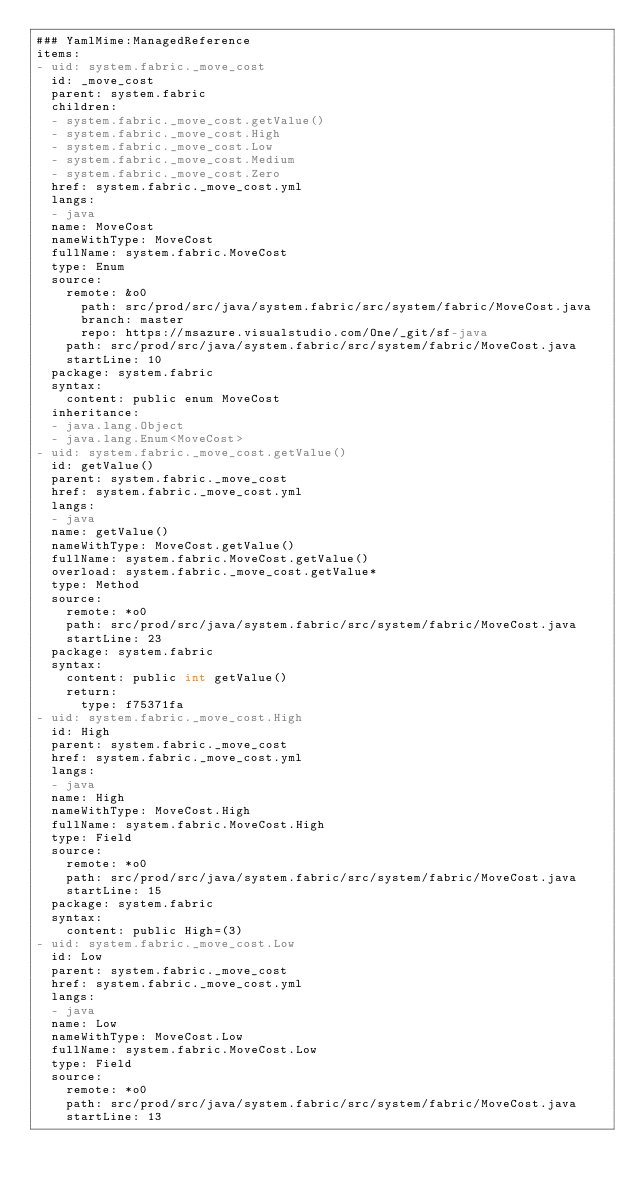Convert code to text. <code><loc_0><loc_0><loc_500><loc_500><_YAML_>### YamlMime:ManagedReference
items:
- uid: system.fabric._move_cost
  id: _move_cost
  parent: system.fabric
  children:
  - system.fabric._move_cost.getValue()
  - system.fabric._move_cost.High
  - system.fabric._move_cost.Low
  - system.fabric._move_cost.Medium
  - system.fabric._move_cost.Zero
  href: system.fabric._move_cost.yml
  langs:
  - java
  name: MoveCost
  nameWithType: MoveCost
  fullName: system.fabric.MoveCost
  type: Enum
  source:
    remote: &o0
      path: src/prod/src/java/system.fabric/src/system/fabric/MoveCost.java
      branch: master
      repo: https://msazure.visualstudio.com/One/_git/sf-java
    path: src/prod/src/java/system.fabric/src/system/fabric/MoveCost.java
    startLine: 10
  package: system.fabric
  syntax:
    content: public enum MoveCost
  inheritance:
  - java.lang.Object
  - java.lang.Enum<MoveCost>
- uid: system.fabric._move_cost.getValue()
  id: getValue()
  parent: system.fabric._move_cost
  href: system.fabric._move_cost.yml
  langs:
  - java
  name: getValue()
  nameWithType: MoveCost.getValue()
  fullName: system.fabric.MoveCost.getValue()
  overload: system.fabric._move_cost.getValue*
  type: Method
  source:
    remote: *o0
    path: src/prod/src/java/system.fabric/src/system/fabric/MoveCost.java
    startLine: 23
  package: system.fabric
  syntax:
    content: public int getValue()
    return:
      type: f75371fa
- uid: system.fabric._move_cost.High
  id: High
  parent: system.fabric._move_cost
  href: system.fabric._move_cost.yml
  langs:
  - java
  name: High
  nameWithType: MoveCost.High
  fullName: system.fabric.MoveCost.High
  type: Field
  source:
    remote: *o0
    path: src/prod/src/java/system.fabric/src/system/fabric/MoveCost.java
    startLine: 15
  package: system.fabric
  syntax:
    content: public High=(3)
- uid: system.fabric._move_cost.Low
  id: Low
  parent: system.fabric._move_cost
  href: system.fabric._move_cost.yml
  langs:
  - java
  name: Low
  nameWithType: MoveCost.Low
  fullName: system.fabric.MoveCost.Low
  type: Field
  source:
    remote: *o0
    path: src/prod/src/java/system.fabric/src/system/fabric/MoveCost.java
    startLine: 13</code> 